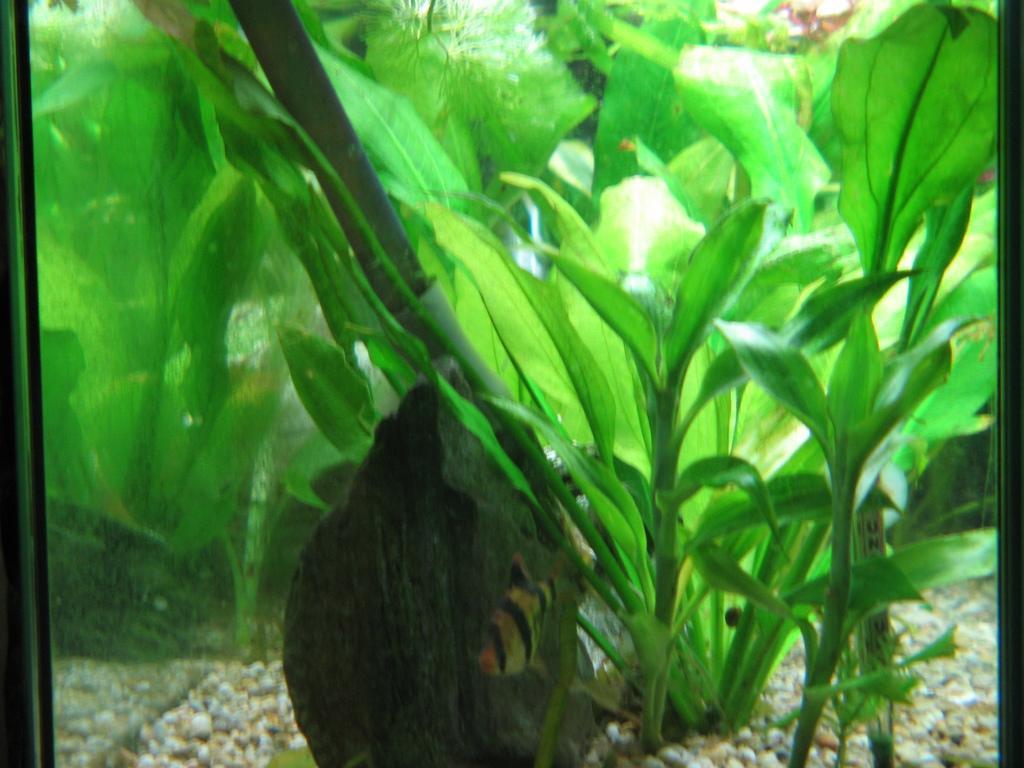How would you summarize this image in a sentence or two? In the image in the center, we can see one aquarium. In the aquarium, we can see stones and plants. 